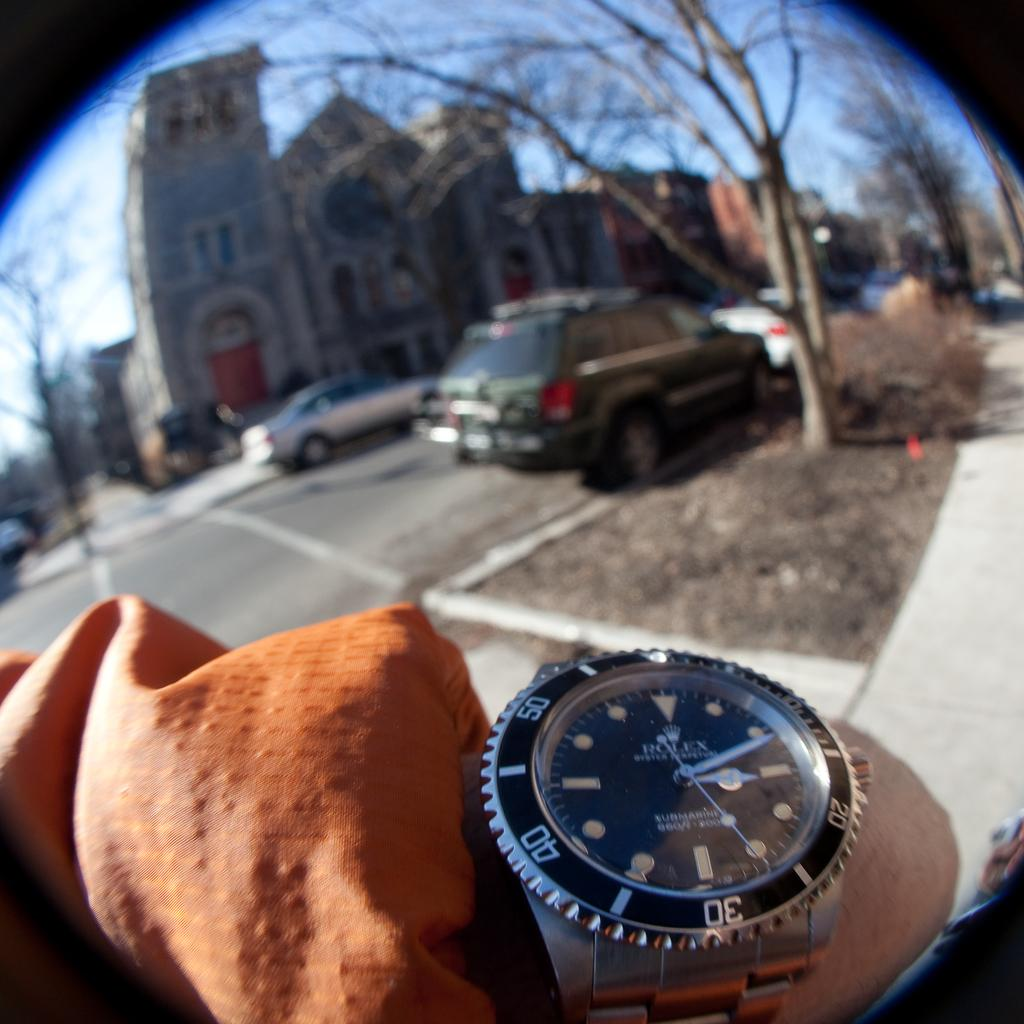Provide a one-sentence caption for the provided image. A person stands in a parking lot and shows their Rolex watch to the camera. 